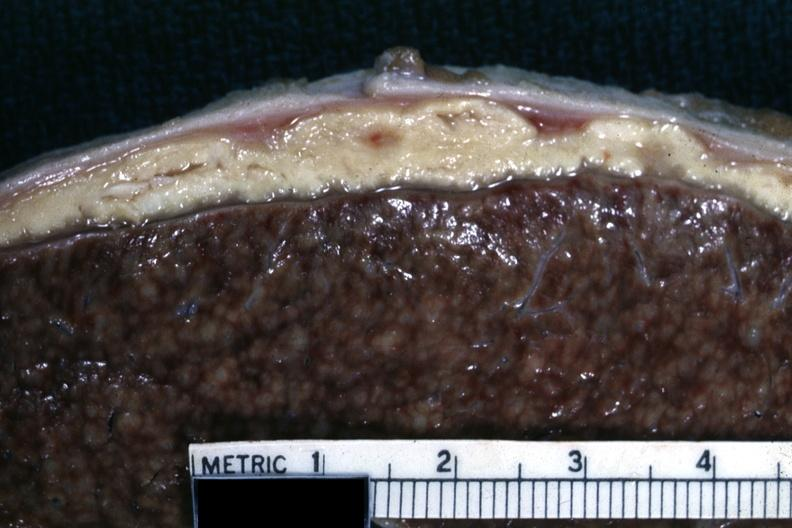s opened abdominal cavity with massive tumor in omentum none apparent in liver nor over peritoneal surfaces gut present?
Answer the question using a single word or phrase. No 